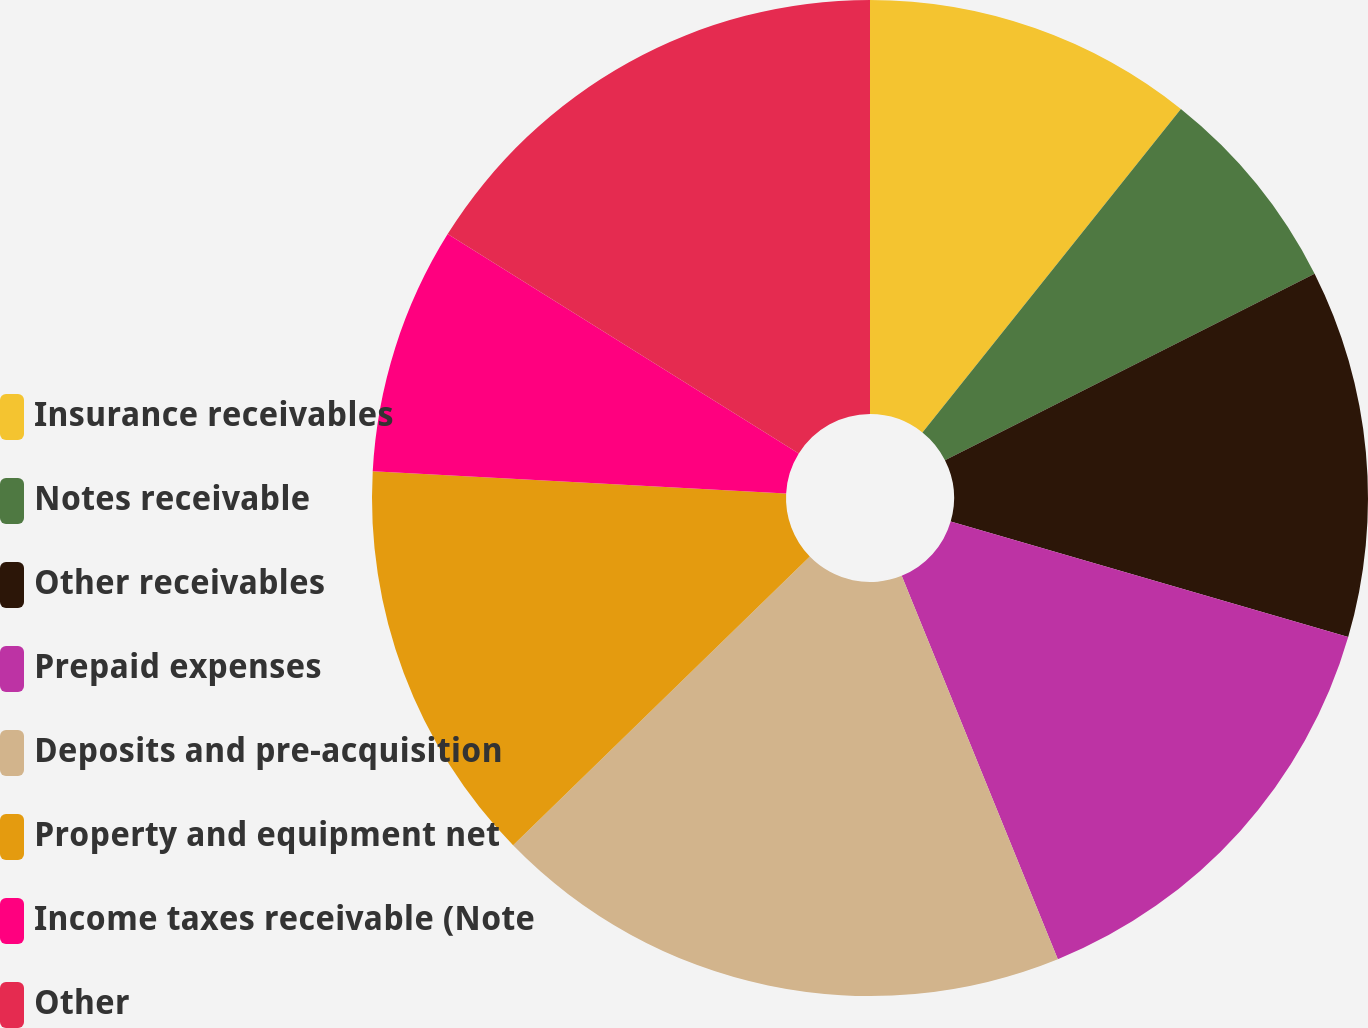Convert chart. <chart><loc_0><loc_0><loc_500><loc_500><pie_chart><fcel>Insurance receivables<fcel>Notes receivable<fcel>Other receivables<fcel>Prepaid expenses<fcel>Deposits and pre-acquisition<fcel>Property and equipment net<fcel>Income taxes receivable (Note<fcel>Other<nl><fcel>10.73%<fcel>6.83%<fcel>11.94%<fcel>14.34%<fcel>18.87%<fcel>13.14%<fcel>8.03%<fcel>16.11%<nl></chart> 